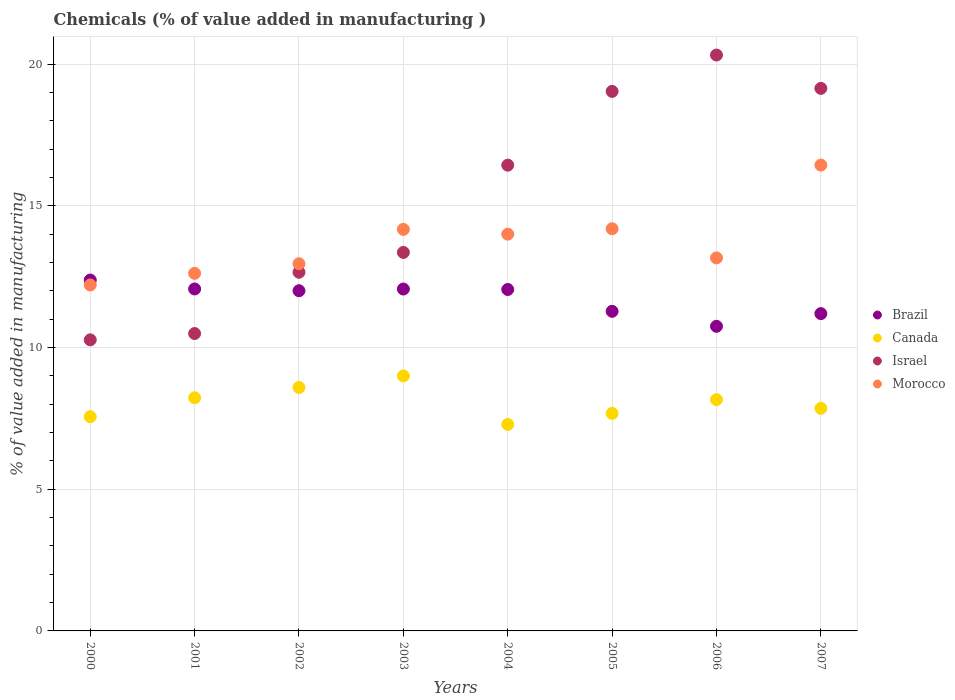How many different coloured dotlines are there?
Give a very brief answer. 4. Is the number of dotlines equal to the number of legend labels?
Your response must be concise. Yes. What is the value added in manufacturing chemicals in Morocco in 2002?
Keep it short and to the point. 12.96. Across all years, what is the maximum value added in manufacturing chemicals in Israel?
Ensure brevity in your answer.  20.32. Across all years, what is the minimum value added in manufacturing chemicals in Brazil?
Your answer should be very brief. 10.75. In which year was the value added in manufacturing chemicals in Brazil maximum?
Provide a succinct answer. 2000. In which year was the value added in manufacturing chemicals in Brazil minimum?
Provide a succinct answer. 2006. What is the total value added in manufacturing chemicals in Morocco in the graph?
Your answer should be very brief. 109.75. What is the difference between the value added in manufacturing chemicals in Israel in 2000 and that in 2002?
Offer a terse response. -2.39. What is the difference between the value added in manufacturing chemicals in Israel in 2006 and the value added in manufacturing chemicals in Morocco in 2001?
Provide a succinct answer. 7.7. What is the average value added in manufacturing chemicals in Israel per year?
Ensure brevity in your answer.  15.21. In the year 2003, what is the difference between the value added in manufacturing chemicals in Morocco and value added in manufacturing chemicals in Canada?
Offer a very short reply. 5.17. What is the ratio of the value added in manufacturing chemicals in Israel in 2000 to that in 2004?
Provide a succinct answer. 0.62. Is the value added in manufacturing chemicals in Israel in 2004 less than that in 2006?
Provide a short and direct response. Yes. What is the difference between the highest and the second highest value added in manufacturing chemicals in Brazil?
Provide a succinct answer. 0.31. What is the difference between the highest and the lowest value added in manufacturing chemicals in Brazil?
Offer a very short reply. 1.63. Is the sum of the value added in manufacturing chemicals in Israel in 2000 and 2006 greater than the maximum value added in manufacturing chemicals in Brazil across all years?
Keep it short and to the point. Yes. Is it the case that in every year, the sum of the value added in manufacturing chemicals in Israel and value added in manufacturing chemicals in Brazil  is greater than the sum of value added in manufacturing chemicals in Morocco and value added in manufacturing chemicals in Canada?
Provide a succinct answer. Yes. Is the value added in manufacturing chemicals in Brazil strictly greater than the value added in manufacturing chemicals in Morocco over the years?
Provide a succinct answer. No. How many years are there in the graph?
Keep it short and to the point. 8. What is the difference between two consecutive major ticks on the Y-axis?
Your response must be concise. 5. Does the graph contain any zero values?
Give a very brief answer. No. How many legend labels are there?
Keep it short and to the point. 4. What is the title of the graph?
Your answer should be compact. Chemicals (% of value added in manufacturing ). Does "Norway" appear as one of the legend labels in the graph?
Your answer should be compact. No. What is the label or title of the X-axis?
Your response must be concise. Years. What is the label or title of the Y-axis?
Offer a very short reply. % of value added in manufacturing. What is the % of value added in manufacturing in Brazil in 2000?
Your answer should be very brief. 12.38. What is the % of value added in manufacturing of Canada in 2000?
Make the answer very short. 7.56. What is the % of value added in manufacturing of Israel in 2000?
Your answer should be very brief. 10.27. What is the % of value added in manufacturing in Morocco in 2000?
Ensure brevity in your answer.  12.21. What is the % of value added in manufacturing in Brazil in 2001?
Offer a terse response. 12.07. What is the % of value added in manufacturing in Canada in 2001?
Your answer should be compact. 8.23. What is the % of value added in manufacturing in Israel in 2001?
Your answer should be compact. 10.49. What is the % of value added in manufacturing in Morocco in 2001?
Offer a very short reply. 12.62. What is the % of value added in manufacturing of Brazil in 2002?
Offer a terse response. 12. What is the % of value added in manufacturing of Canada in 2002?
Your response must be concise. 8.59. What is the % of value added in manufacturing in Israel in 2002?
Provide a short and direct response. 12.66. What is the % of value added in manufacturing of Morocco in 2002?
Provide a succinct answer. 12.96. What is the % of value added in manufacturing of Brazil in 2003?
Provide a succinct answer. 12.06. What is the % of value added in manufacturing in Canada in 2003?
Your answer should be compact. 9. What is the % of value added in manufacturing of Israel in 2003?
Make the answer very short. 13.36. What is the % of value added in manufacturing of Morocco in 2003?
Ensure brevity in your answer.  14.17. What is the % of value added in manufacturing of Brazil in 2004?
Your response must be concise. 12.05. What is the % of value added in manufacturing of Canada in 2004?
Your answer should be very brief. 7.29. What is the % of value added in manufacturing in Israel in 2004?
Provide a succinct answer. 16.43. What is the % of value added in manufacturing in Morocco in 2004?
Give a very brief answer. 14. What is the % of value added in manufacturing of Brazil in 2005?
Ensure brevity in your answer.  11.28. What is the % of value added in manufacturing in Canada in 2005?
Your answer should be very brief. 7.68. What is the % of value added in manufacturing of Israel in 2005?
Your answer should be very brief. 19.04. What is the % of value added in manufacturing of Morocco in 2005?
Offer a terse response. 14.19. What is the % of value added in manufacturing in Brazil in 2006?
Make the answer very short. 10.75. What is the % of value added in manufacturing of Canada in 2006?
Make the answer very short. 8.16. What is the % of value added in manufacturing in Israel in 2006?
Ensure brevity in your answer.  20.32. What is the % of value added in manufacturing in Morocco in 2006?
Provide a short and direct response. 13.16. What is the % of value added in manufacturing in Brazil in 2007?
Provide a succinct answer. 11.2. What is the % of value added in manufacturing in Canada in 2007?
Ensure brevity in your answer.  7.85. What is the % of value added in manufacturing in Israel in 2007?
Provide a short and direct response. 19.14. What is the % of value added in manufacturing in Morocco in 2007?
Your answer should be compact. 16.44. Across all years, what is the maximum % of value added in manufacturing in Brazil?
Ensure brevity in your answer.  12.38. Across all years, what is the maximum % of value added in manufacturing of Canada?
Ensure brevity in your answer.  9. Across all years, what is the maximum % of value added in manufacturing of Israel?
Your response must be concise. 20.32. Across all years, what is the maximum % of value added in manufacturing in Morocco?
Keep it short and to the point. 16.44. Across all years, what is the minimum % of value added in manufacturing in Brazil?
Give a very brief answer. 10.75. Across all years, what is the minimum % of value added in manufacturing in Canada?
Offer a terse response. 7.29. Across all years, what is the minimum % of value added in manufacturing in Israel?
Your response must be concise. 10.27. Across all years, what is the minimum % of value added in manufacturing of Morocco?
Make the answer very short. 12.21. What is the total % of value added in manufacturing of Brazil in the graph?
Keep it short and to the point. 93.79. What is the total % of value added in manufacturing in Canada in the graph?
Your response must be concise. 64.35. What is the total % of value added in manufacturing in Israel in the graph?
Offer a very short reply. 121.72. What is the total % of value added in manufacturing in Morocco in the graph?
Your answer should be compact. 109.75. What is the difference between the % of value added in manufacturing of Brazil in 2000 and that in 2001?
Ensure brevity in your answer.  0.32. What is the difference between the % of value added in manufacturing of Canada in 2000 and that in 2001?
Offer a very short reply. -0.67. What is the difference between the % of value added in manufacturing in Israel in 2000 and that in 2001?
Ensure brevity in your answer.  -0.22. What is the difference between the % of value added in manufacturing of Morocco in 2000 and that in 2001?
Offer a terse response. -0.41. What is the difference between the % of value added in manufacturing of Brazil in 2000 and that in 2002?
Your answer should be very brief. 0.38. What is the difference between the % of value added in manufacturing of Canada in 2000 and that in 2002?
Your response must be concise. -1.03. What is the difference between the % of value added in manufacturing of Israel in 2000 and that in 2002?
Keep it short and to the point. -2.38. What is the difference between the % of value added in manufacturing in Morocco in 2000 and that in 2002?
Your answer should be compact. -0.75. What is the difference between the % of value added in manufacturing of Brazil in 2000 and that in 2003?
Provide a short and direct response. 0.32. What is the difference between the % of value added in manufacturing of Canada in 2000 and that in 2003?
Provide a succinct answer. -1.44. What is the difference between the % of value added in manufacturing in Israel in 2000 and that in 2003?
Your answer should be very brief. -3.08. What is the difference between the % of value added in manufacturing in Morocco in 2000 and that in 2003?
Give a very brief answer. -1.96. What is the difference between the % of value added in manufacturing in Brazil in 2000 and that in 2004?
Your response must be concise. 0.33. What is the difference between the % of value added in manufacturing of Canada in 2000 and that in 2004?
Ensure brevity in your answer.  0.27. What is the difference between the % of value added in manufacturing in Israel in 2000 and that in 2004?
Offer a terse response. -6.16. What is the difference between the % of value added in manufacturing in Morocco in 2000 and that in 2004?
Your response must be concise. -1.79. What is the difference between the % of value added in manufacturing of Brazil in 2000 and that in 2005?
Offer a very short reply. 1.1. What is the difference between the % of value added in manufacturing of Canada in 2000 and that in 2005?
Offer a very short reply. -0.12. What is the difference between the % of value added in manufacturing of Israel in 2000 and that in 2005?
Ensure brevity in your answer.  -8.77. What is the difference between the % of value added in manufacturing of Morocco in 2000 and that in 2005?
Your answer should be very brief. -1.98. What is the difference between the % of value added in manufacturing of Brazil in 2000 and that in 2006?
Provide a short and direct response. 1.63. What is the difference between the % of value added in manufacturing in Canada in 2000 and that in 2006?
Keep it short and to the point. -0.6. What is the difference between the % of value added in manufacturing of Israel in 2000 and that in 2006?
Your answer should be very brief. -10.05. What is the difference between the % of value added in manufacturing of Morocco in 2000 and that in 2006?
Keep it short and to the point. -0.95. What is the difference between the % of value added in manufacturing of Brazil in 2000 and that in 2007?
Keep it short and to the point. 1.18. What is the difference between the % of value added in manufacturing in Canada in 2000 and that in 2007?
Your answer should be compact. -0.29. What is the difference between the % of value added in manufacturing in Israel in 2000 and that in 2007?
Provide a short and direct response. -8.87. What is the difference between the % of value added in manufacturing in Morocco in 2000 and that in 2007?
Ensure brevity in your answer.  -4.23. What is the difference between the % of value added in manufacturing of Brazil in 2001 and that in 2002?
Provide a succinct answer. 0.06. What is the difference between the % of value added in manufacturing in Canada in 2001 and that in 2002?
Your answer should be very brief. -0.36. What is the difference between the % of value added in manufacturing of Israel in 2001 and that in 2002?
Your response must be concise. -2.16. What is the difference between the % of value added in manufacturing in Morocco in 2001 and that in 2002?
Keep it short and to the point. -0.34. What is the difference between the % of value added in manufacturing of Brazil in 2001 and that in 2003?
Keep it short and to the point. 0. What is the difference between the % of value added in manufacturing of Canada in 2001 and that in 2003?
Offer a terse response. -0.77. What is the difference between the % of value added in manufacturing of Israel in 2001 and that in 2003?
Your answer should be compact. -2.86. What is the difference between the % of value added in manufacturing of Morocco in 2001 and that in 2003?
Keep it short and to the point. -1.55. What is the difference between the % of value added in manufacturing of Brazil in 2001 and that in 2004?
Your answer should be very brief. 0.02. What is the difference between the % of value added in manufacturing in Canada in 2001 and that in 2004?
Provide a succinct answer. 0.94. What is the difference between the % of value added in manufacturing in Israel in 2001 and that in 2004?
Make the answer very short. -5.94. What is the difference between the % of value added in manufacturing in Morocco in 2001 and that in 2004?
Ensure brevity in your answer.  -1.38. What is the difference between the % of value added in manufacturing of Brazil in 2001 and that in 2005?
Make the answer very short. 0.79. What is the difference between the % of value added in manufacturing in Canada in 2001 and that in 2005?
Your answer should be compact. 0.55. What is the difference between the % of value added in manufacturing of Israel in 2001 and that in 2005?
Keep it short and to the point. -8.54. What is the difference between the % of value added in manufacturing in Morocco in 2001 and that in 2005?
Provide a succinct answer. -1.57. What is the difference between the % of value added in manufacturing in Brazil in 2001 and that in 2006?
Offer a terse response. 1.32. What is the difference between the % of value added in manufacturing in Canada in 2001 and that in 2006?
Make the answer very short. 0.06. What is the difference between the % of value added in manufacturing of Israel in 2001 and that in 2006?
Your answer should be very brief. -9.83. What is the difference between the % of value added in manufacturing in Morocco in 2001 and that in 2006?
Provide a succinct answer. -0.54. What is the difference between the % of value added in manufacturing in Brazil in 2001 and that in 2007?
Provide a succinct answer. 0.87. What is the difference between the % of value added in manufacturing in Canada in 2001 and that in 2007?
Your answer should be very brief. 0.37. What is the difference between the % of value added in manufacturing in Israel in 2001 and that in 2007?
Make the answer very short. -8.65. What is the difference between the % of value added in manufacturing in Morocco in 2001 and that in 2007?
Make the answer very short. -3.82. What is the difference between the % of value added in manufacturing of Brazil in 2002 and that in 2003?
Your response must be concise. -0.06. What is the difference between the % of value added in manufacturing of Canada in 2002 and that in 2003?
Keep it short and to the point. -0.41. What is the difference between the % of value added in manufacturing in Israel in 2002 and that in 2003?
Your answer should be compact. -0.7. What is the difference between the % of value added in manufacturing in Morocco in 2002 and that in 2003?
Your answer should be compact. -1.21. What is the difference between the % of value added in manufacturing in Brazil in 2002 and that in 2004?
Your response must be concise. -0.04. What is the difference between the % of value added in manufacturing of Canada in 2002 and that in 2004?
Provide a short and direct response. 1.3. What is the difference between the % of value added in manufacturing of Israel in 2002 and that in 2004?
Your response must be concise. -3.78. What is the difference between the % of value added in manufacturing of Morocco in 2002 and that in 2004?
Provide a short and direct response. -1.04. What is the difference between the % of value added in manufacturing of Brazil in 2002 and that in 2005?
Provide a short and direct response. 0.73. What is the difference between the % of value added in manufacturing of Canada in 2002 and that in 2005?
Keep it short and to the point. 0.92. What is the difference between the % of value added in manufacturing of Israel in 2002 and that in 2005?
Give a very brief answer. -6.38. What is the difference between the % of value added in manufacturing of Morocco in 2002 and that in 2005?
Your answer should be compact. -1.24. What is the difference between the % of value added in manufacturing of Brazil in 2002 and that in 2006?
Give a very brief answer. 1.26. What is the difference between the % of value added in manufacturing of Canada in 2002 and that in 2006?
Give a very brief answer. 0.43. What is the difference between the % of value added in manufacturing of Israel in 2002 and that in 2006?
Your answer should be very brief. -7.66. What is the difference between the % of value added in manufacturing in Morocco in 2002 and that in 2006?
Provide a succinct answer. -0.21. What is the difference between the % of value added in manufacturing of Brazil in 2002 and that in 2007?
Your response must be concise. 0.81. What is the difference between the % of value added in manufacturing of Canada in 2002 and that in 2007?
Provide a short and direct response. 0.74. What is the difference between the % of value added in manufacturing of Israel in 2002 and that in 2007?
Offer a very short reply. -6.49. What is the difference between the % of value added in manufacturing of Morocco in 2002 and that in 2007?
Provide a succinct answer. -3.48. What is the difference between the % of value added in manufacturing of Brazil in 2003 and that in 2004?
Make the answer very short. 0.02. What is the difference between the % of value added in manufacturing in Canada in 2003 and that in 2004?
Give a very brief answer. 1.71. What is the difference between the % of value added in manufacturing of Israel in 2003 and that in 2004?
Offer a terse response. -3.08. What is the difference between the % of value added in manufacturing of Morocco in 2003 and that in 2004?
Offer a terse response. 0.17. What is the difference between the % of value added in manufacturing in Brazil in 2003 and that in 2005?
Keep it short and to the point. 0.79. What is the difference between the % of value added in manufacturing of Canada in 2003 and that in 2005?
Make the answer very short. 1.32. What is the difference between the % of value added in manufacturing in Israel in 2003 and that in 2005?
Your answer should be very brief. -5.68. What is the difference between the % of value added in manufacturing of Morocco in 2003 and that in 2005?
Make the answer very short. -0.02. What is the difference between the % of value added in manufacturing in Brazil in 2003 and that in 2006?
Your answer should be compact. 1.32. What is the difference between the % of value added in manufacturing in Canada in 2003 and that in 2006?
Your response must be concise. 0.84. What is the difference between the % of value added in manufacturing of Israel in 2003 and that in 2006?
Provide a short and direct response. -6.96. What is the difference between the % of value added in manufacturing in Morocco in 2003 and that in 2006?
Offer a terse response. 1.01. What is the difference between the % of value added in manufacturing in Brazil in 2003 and that in 2007?
Your answer should be very brief. 0.87. What is the difference between the % of value added in manufacturing in Canada in 2003 and that in 2007?
Your answer should be very brief. 1.14. What is the difference between the % of value added in manufacturing in Israel in 2003 and that in 2007?
Make the answer very short. -5.79. What is the difference between the % of value added in manufacturing of Morocco in 2003 and that in 2007?
Offer a very short reply. -2.27. What is the difference between the % of value added in manufacturing of Brazil in 2004 and that in 2005?
Your answer should be very brief. 0.77. What is the difference between the % of value added in manufacturing in Canada in 2004 and that in 2005?
Give a very brief answer. -0.39. What is the difference between the % of value added in manufacturing of Israel in 2004 and that in 2005?
Offer a terse response. -2.6. What is the difference between the % of value added in manufacturing of Morocco in 2004 and that in 2005?
Keep it short and to the point. -0.19. What is the difference between the % of value added in manufacturing in Brazil in 2004 and that in 2006?
Offer a terse response. 1.3. What is the difference between the % of value added in manufacturing in Canada in 2004 and that in 2006?
Make the answer very short. -0.88. What is the difference between the % of value added in manufacturing of Israel in 2004 and that in 2006?
Provide a succinct answer. -3.89. What is the difference between the % of value added in manufacturing of Morocco in 2004 and that in 2006?
Provide a short and direct response. 0.84. What is the difference between the % of value added in manufacturing in Brazil in 2004 and that in 2007?
Your answer should be compact. 0.85. What is the difference between the % of value added in manufacturing in Canada in 2004 and that in 2007?
Your answer should be compact. -0.57. What is the difference between the % of value added in manufacturing in Israel in 2004 and that in 2007?
Ensure brevity in your answer.  -2.71. What is the difference between the % of value added in manufacturing of Morocco in 2004 and that in 2007?
Give a very brief answer. -2.44. What is the difference between the % of value added in manufacturing of Brazil in 2005 and that in 2006?
Keep it short and to the point. 0.53. What is the difference between the % of value added in manufacturing of Canada in 2005 and that in 2006?
Give a very brief answer. -0.49. What is the difference between the % of value added in manufacturing of Israel in 2005 and that in 2006?
Offer a terse response. -1.28. What is the difference between the % of value added in manufacturing of Morocco in 2005 and that in 2006?
Make the answer very short. 1.03. What is the difference between the % of value added in manufacturing of Brazil in 2005 and that in 2007?
Provide a short and direct response. 0.08. What is the difference between the % of value added in manufacturing of Canada in 2005 and that in 2007?
Provide a short and direct response. -0.18. What is the difference between the % of value added in manufacturing in Israel in 2005 and that in 2007?
Your response must be concise. -0.11. What is the difference between the % of value added in manufacturing of Morocco in 2005 and that in 2007?
Offer a very short reply. -2.25. What is the difference between the % of value added in manufacturing in Brazil in 2006 and that in 2007?
Provide a short and direct response. -0.45. What is the difference between the % of value added in manufacturing in Canada in 2006 and that in 2007?
Your answer should be very brief. 0.31. What is the difference between the % of value added in manufacturing of Israel in 2006 and that in 2007?
Make the answer very short. 1.18. What is the difference between the % of value added in manufacturing in Morocco in 2006 and that in 2007?
Ensure brevity in your answer.  -3.28. What is the difference between the % of value added in manufacturing in Brazil in 2000 and the % of value added in manufacturing in Canada in 2001?
Keep it short and to the point. 4.15. What is the difference between the % of value added in manufacturing of Brazil in 2000 and the % of value added in manufacturing of Israel in 2001?
Your answer should be compact. 1.89. What is the difference between the % of value added in manufacturing in Brazil in 2000 and the % of value added in manufacturing in Morocco in 2001?
Offer a very short reply. -0.24. What is the difference between the % of value added in manufacturing in Canada in 2000 and the % of value added in manufacturing in Israel in 2001?
Your response must be concise. -2.93. What is the difference between the % of value added in manufacturing in Canada in 2000 and the % of value added in manufacturing in Morocco in 2001?
Give a very brief answer. -5.06. What is the difference between the % of value added in manufacturing in Israel in 2000 and the % of value added in manufacturing in Morocco in 2001?
Make the answer very short. -2.35. What is the difference between the % of value added in manufacturing in Brazil in 2000 and the % of value added in manufacturing in Canada in 2002?
Offer a very short reply. 3.79. What is the difference between the % of value added in manufacturing in Brazil in 2000 and the % of value added in manufacturing in Israel in 2002?
Your answer should be very brief. -0.27. What is the difference between the % of value added in manufacturing of Brazil in 2000 and the % of value added in manufacturing of Morocco in 2002?
Provide a succinct answer. -0.58. What is the difference between the % of value added in manufacturing in Canada in 2000 and the % of value added in manufacturing in Israel in 2002?
Make the answer very short. -5.1. What is the difference between the % of value added in manufacturing in Canada in 2000 and the % of value added in manufacturing in Morocco in 2002?
Offer a very short reply. -5.4. What is the difference between the % of value added in manufacturing in Israel in 2000 and the % of value added in manufacturing in Morocco in 2002?
Your answer should be compact. -2.69. What is the difference between the % of value added in manufacturing in Brazil in 2000 and the % of value added in manufacturing in Canada in 2003?
Ensure brevity in your answer.  3.38. What is the difference between the % of value added in manufacturing in Brazil in 2000 and the % of value added in manufacturing in Israel in 2003?
Your response must be concise. -0.97. What is the difference between the % of value added in manufacturing of Brazil in 2000 and the % of value added in manufacturing of Morocco in 2003?
Offer a very short reply. -1.79. What is the difference between the % of value added in manufacturing of Canada in 2000 and the % of value added in manufacturing of Israel in 2003?
Provide a short and direct response. -5.8. What is the difference between the % of value added in manufacturing of Canada in 2000 and the % of value added in manufacturing of Morocco in 2003?
Give a very brief answer. -6.61. What is the difference between the % of value added in manufacturing in Israel in 2000 and the % of value added in manufacturing in Morocco in 2003?
Give a very brief answer. -3.9. What is the difference between the % of value added in manufacturing of Brazil in 2000 and the % of value added in manufacturing of Canada in 2004?
Your response must be concise. 5.1. What is the difference between the % of value added in manufacturing in Brazil in 2000 and the % of value added in manufacturing in Israel in 2004?
Ensure brevity in your answer.  -4.05. What is the difference between the % of value added in manufacturing in Brazil in 2000 and the % of value added in manufacturing in Morocco in 2004?
Provide a short and direct response. -1.62. What is the difference between the % of value added in manufacturing in Canada in 2000 and the % of value added in manufacturing in Israel in 2004?
Your answer should be compact. -8.88. What is the difference between the % of value added in manufacturing of Canada in 2000 and the % of value added in manufacturing of Morocco in 2004?
Make the answer very short. -6.44. What is the difference between the % of value added in manufacturing of Israel in 2000 and the % of value added in manufacturing of Morocco in 2004?
Your response must be concise. -3.73. What is the difference between the % of value added in manufacturing of Brazil in 2000 and the % of value added in manufacturing of Canada in 2005?
Your response must be concise. 4.71. What is the difference between the % of value added in manufacturing in Brazil in 2000 and the % of value added in manufacturing in Israel in 2005?
Ensure brevity in your answer.  -6.66. What is the difference between the % of value added in manufacturing of Brazil in 2000 and the % of value added in manufacturing of Morocco in 2005?
Give a very brief answer. -1.81. What is the difference between the % of value added in manufacturing in Canada in 2000 and the % of value added in manufacturing in Israel in 2005?
Provide a succinct answer. -11.48. What is the difference between the % of value added in manufacturing in Canada in 2000 and the % of value added in manufacturing in Morocco in 2005?
Provide a short and direct response. -6.63. What is the difference between the % of value added in manufacturing of Israel in 2000 and the % of value added in manufacturing of Morocco in 2005?
Your response must be concise. -3.92. What is the difference between the % of value added in manufacturing of Brazil in 2000 and the % of value added in manufacturing of Canada in 2006?
Make the answer very short. 4.22. What is the difference between the % of value added in manufacturing of Brazil in 2000 and the % of value added in manufacturing of Israel in 2006?
Keep it short and to the point. -7.94. What is the difference between the % of value added in manufacturing of Brazil in 2000 and the % of value added in manufacturing of Morocco in 2006?
Offer a terse response. -0.78. What is the difference between the % of value added in manufacturing of Canada in 2000 and the % of value added in manufacturing of Israel in 2006?
Ensure brevity in your answer.  -12.76. What is the difference between the % of value added in manufacturing of Canada in 2000 and the % of value added in manufacturing of Morocco in 2006?
Your answer should be compact. -5.6. What is the difference between the % of value added in manufacturing in Israel in 2000 and the % of value added in manufacturing in Morocco in 2006?
Ensure brevity in your answer.  -2.89. What is the difference between the % of value added in manufacturing in Brazil in 2000 and the % of value added in manufacturing in Canada in 2007?
Your answer should be very brief. 4.53. What is the difference between the % of value added in manufacturing in Brazil in 2000 and the % of value added in manufacturing in Israel in 2007?
Give a very brief answer. -6.76. What is the difference between the % of value added in manufacturing in Brazil in 2000 and the % of value added in manufacturing in Morocco in 2007?
Make the answer very short. -4.06. What is the difference between the % of value added in manufacturing in Canada in 2000 and the % of value added in manufacturing in Israel in 2007?
Offer a terse response. -11.58. What is the difference between the % of value added in manufacturing of Canada in 2000 and the % of value added in manufacturing of Morocco in 2007?
Keep it short and to the point. -8.88. What is the difference between the % of value added in manufacturing of Israel in 2000 and the % of value added in manufacturing of Morocco in 2007?
Provide a short and direct response. -6.17. What is the difference between the % of value added in manufacturing of Brazil in 2001 and the % of value added in manufacturing of Canada in 2002?
Your response must be concise. 3.48. What is the difference between the % of value added in manufacturing in Brazil in 2001 and the % of value added in manufacturing in Israel in 2002?
Make the answer very short. -0.59. What is the difference between the % of value added in manufacturing in Brazil in 2001 and the % of value added in manufacturing in Morocco in 2002?
Keep it short and to the point. -0.89. What is the difference between the % of value added in manufacturing of Canada in 2001 and the % of value added in manufacturing of Israel in 2002?
Give a very brief answer. -4.43. What is the difference between the % of value added in manufacturing in Canada in 2001 and the % of value added in manufacturing in Morocco in 2002?
Offer a terse response. -4.73. What is the difference between the % of value added in manufacturing of Israel in 2001 and the % of value added in manufacturing of Morocco in 2002?
Keep it short and to the point. -2.46. What is the difference between the % of value added in manufacturing in Brazil in 2001 and the % of value added in manufacturing in Canada in 2003?
Provide a short and direct response. 3.07. What is the difference between the % of value added in manufacturing of Brazil in 2001 and the % of value added in manufacturing of Israel in 2003?
Ensure brevity in your answer.  -1.29. What is the difference between the % of value added in manufacturing of Brazil in 2001 and the % of value added in manufacturing of Morocco in 2003?
Provide a short and direct response. -2.1. What is the difference between the % of value added in manufacturing of Canada in 2001 and the % of value added in manufacturing of Israel in 2003?
Your answer should be compact. -5.13. What is the difference between the % of value added in manufacturing in Canada in 2001 and the % of value added in manufacturing in Morocco in 2003?
Keep it short and to the point. -5.94. What is the difference between the % of value added in manufacturing in Israel in 2001 and the % of value added in manufacturing in Morocco in 2003?
Your answer should be compact. -3.68. What is the difference between the % of value added in manufacturing of Brazil in 2001 and the % of value added in manufacturing of Canada in 2004?
Your response must be concise. 4.78. What is the difference between the % of value added in manufacturing in Brazil in 2001 and the % of value added in manufacturing in Israel in 2004?
Keep it short and to the point. -4.37. What is the difference between the % of value added in manufacturing of Brazil in 2001 and the % of value added in manufacturing of Morocco in 2004?
Your answer should be very brief. -1.93. What is the difference between the % of value added in manufacturing of Canada in 2001 and the % of value added in manufacturing of Israel in 2004?
Make the answer very short. -8.21. What is the difference between the % of value added in manufacturing in Canada in 2001 and the % of value added in manufacturing in Morocco in 2004?
Offer a terse response. -5.77. What is the difference between the % of value added in manufacturing in Israel in 2001 and the % of value added in manufacturing in Morocco in 2004?
Your answer should be compact. -3.51. What is the difference between the % of value added in manufacturing in Brazil in 2001 and the % of value added in manufacturing in Canada in 2005?
Provide a short and direct response. 4.39. What is the difference between the % of value added in manufacturing in Brazil in 2001 and the % of value added in manufacturing in Israel in 2005?
Give a very brief answer. -6.97. What is the difference between the % of value added in manufacturing in Brazil in 2001 and the % of value added in manufacturing in Morocco in 2005?
Provide a succinct answer. -2.13. What is the difference between the % of value added in manufacturing of Canada in 2001 and the % of value added in manufacturing of Israel in 2005?
Your response must be concise. -10.81. What is the difference between the % of value added in manufacturing in Canada in 2001 and the % of value added in manufacturing in Morocco in 2005?
Provide a succinct answer. -5.96. What is the difference between the % of value added in manufacturing of Israel in 2001 and the % of value added in manufacturing of Morocco in 2005?
Give a very brief answer. -3.7. What is the difference between the % of value added in manufacturing of Brazil in 2001 and the % of value added in manufacturing of Canada in 2006?
Ensure brevity in your answer.  3.9. What is the difference between the % of value added in manufacturing in Brazil in 2001 and the % of value added in manufacturing in Israel in 2006?
Ensure brevity in your answer.  -8.25. What is the difference between the % of value added in manufacturing in Brazil in 2001 and the % of value added in manufacturing in Morocco in 2006?
Your answer should be very brief. -1.1. What is the difference between the % of value added in manufacturing in Canada in 2001 and the % of value added in manufacturing in Israel in 2006?
Your response must be concise. -12.09. What is the difference between the % of value added in manufacturing in Canada in 2001 and the % of value added in manufacturing in Morocco in 2006?
Keep it short and to the point. -4.94. What is the difference between the % of value added in manufacturing in Israel in 2001 and the % of value added in manufacturing in Morocco in 2006?
Offer a terse response. -2.67. What is the difference between the % of value added in manufacturing in Brazil in 2001 and the % of value added in manufacturing in Canada in 2007?
Offer a very short reply. 4.21. What is the difference between the % of value added in manufacturing in Brazil in 2001 and the % of value added in manufacturing in Israel in 2007?
Your answer should be very brief. -7.08. What is the difference between the % of value added in manufacturing in Brazil in 2001 and the % of value added in manufacturing in Morocco in 2007?
Offer a terse response. -4.37. What is the difference between the % of value added in manufacturing in Canada in 2001 and the % of value added in manufacturing in Israel in 2007?
Make the answer very short. -10.92. What is the difference between the % of value added in manufacturing in Canada in 2001 and the % of value added in manufacturing in Morocco in 2007?
Ensure brevity in your answer.  -8.21. What is the difference between the % of value added in manufacturing of Israel in 2001 and the % of value added in manufacturing of Morocco in 2007?
Your response must be concise. -5.94. What is the difference between the % of value added in manufacturing of Brazil in 2002 and the % of value added in manufacturing of Canada in 2003?
Make the answer very short. 3.01. What is the difference between the % of value added in manufacturing of Brazil in 2002 and the % of value added in manufacturing of Israel in 2003?
Provide a succinct answer. -1.35. What is the difference between the % of value added in manufacturing of Brazil in 2002 and the % of value added in manufacturing of Morocco in 2003?
Your answer should be very brief. -2.16. What is the difference between the % of value added in manufacturing in Canada in 2002 and the % of value added in manufacturing in Israel in 2003?
Ensure brevity in your answer.  -4.77. What is the difference between the % of value added in manufacturing of Canada in 2002 and the % of value added in manufacturing of Morocco in 2003?
Provide a short and direct response. -5.58. What is the difference between the % of value added in manufacturing of Israel in 2002 and the % of value added in manufacturing of Morocco in 2003?
Your answer should be very brief. -1.51. What is the difference between the % of value added in manufacturing in Brazil in 2002 and the % of value added in manufacturing in Canada in 2004?
Give a very brief answer. 4.72. What is the difference between the % of value added in manufacturing in Brazil in 2002 and the % of value added in manufacturing in Israel in 2004?
Give a very brief answer. -4.43. What is the difference between the % of value added in manufacturing in Brazil in 2002 and the % of value added in manufacturing in Morocco in 2004?
Ensure brevity in your answer.  -2. What is the difference between the % of value added in manufacturing in Canada in 2002 and the % of value added in manufacturing in Israel in 2004?
Keep it short and to the point. -7.84. What is the difference between the % of value added in manufacturing of Canada in 2002 and the % of value added in manufacturing of Morocco in 2004?
Your answer should be compact. -5.41. What is the difference between the % of value added in manufacturing of Israel in 2002 and the % of value added in manufacturing of Morocco in 2004?
Provide a short and direct response. -1.34. What is the difference between the % of value added in manufacturing in Brazil in 2002 and the % of value added in manufacturing in Canada in 2005?
Offer a very short reply. 4.33. What is the difference between the % of value added in manufacturing of Brazil in 2002 and the % of value added in manufacturing of Israel in 2005?
Keep it short and to the point. -7.03. What is the difference between the % of value added in manufacturing in Brazil in 2002 and the % of value added in manufacturing in Morocco in 2005?
Give a very brief answer. -2.19. What is the difference between the % of value added in manufacturing of Canada in 2002 and the % of value added in manufacturing of Israel in 2005?
Your answer should be very brief. -10.45. What is the difference between the % of value added in manufacturing in Canada in 2002 and the % of value added in manufacturing in Morocco in 2005?
Provide a short and direct response. -5.6. What is the difference between the % of value added in manufacturing in Israel in 2002 and the % of value added in manufacturing in Morocco in 2005?
Give a very brief answer. -1.54. What is the difference between the % of value added in manufacturing of Brazil in 2002 and the % of value added in manufacturing of Canada in 2006?
Make the answer very short. 3.84. What is the difference between the % of value added in manufacturing of Brazil in 2002 and the % of value added in manufacturing of Israel in 2006?
Offer a terse response. -8.32. What is the difference between the % of value added in manufacturing of Brazil in 2002 and the % of value added in manufacturing of Morocco in 2006?
Provide a short and direct response. -1.16. What is the difference between the % of value added in manufacturing of Canada in 2002 and the % of value added in manufacturing of Israel in 2006?
Your answer should be compact. -11.73. What is the difference between the % of value added in manufacturing of Canada in 2002 and the % of value added in manufacturing of Morocco in 2006?
Offer a very short reply. -4.57. What is the difference between the % of value added in manufacturing of Israel in 2002 and the % of value added in manufacturing of Morocco in 2006?
Offer a terse response. -0.51. What is the difference between the % of value added in manufacturing in Brazil in 2002 and the % of value added in manufacturing in Canada in 2007?
Your answer should be compact. 4.15. What is the difference between the % of value added in manufacturing in Brazil in 2002 and the % of value added in manufacturing in Israel in 2007?
Offer a terse response. -7.14. What is the difference between the % of value added in manufacturing of Brazil in 2002 and the % of value added in manufacturing of Morocco in 2007?
Give a very brief answer. -4.43. What is the difference between the % of value added in manufacturing of Canada in 2002 and the % of value added in manufacturing of Israel in 2007?
Provide a short and direct response. -10.55. What is the difference between the % of value added in manufacturing of Canada in 2002 and the % of value added in manufacturing of Morocco in 2007?
Offer a terse response. -7.85. What is the difference between the % of value added in manufacturing in Israel in 2002 and the % of value added in manufacturing in Morocco in 2007?
Give a very brief answer. -3.78. What is the difference between the % of value added in manufacturing of Brazil in 2003 and the % of value added in manufacturing of Canada in 2004?
Keep it short and to the point. 4.78. What is the difference between the % of value added in manufacturing of Brazil in 2003 and the % of value added in manufacturing of Israel in 2004?
Your answer should be compact. -4.37. What is the difference between the % of value added in manufacturing in Brazil in 2003 and the % of value added in manufacturing in Morocco in 2004?
Your answer should be compact. -1.94. What is the difference between the % of value added in manufacturing in Canada in 2003 and the % of value added in manufacturing in Israel in 2004?
Offer a terse response. -7.44. What is the difference between the % of value added in manufacturing in Canada in 2003 and the % of value added in manufacturing in Morocco in 2004?
Your answer should be very brief. -5. What is the difference between the % of value added in manufacturing in Israel in 2003 and the % of value added in manufacturing in Morocco in 2004?
Provide a succinct answer. -0.64. What is the difference between the % of value added in manufacturing in Brazil in 2003 and the % of value added in manufacturing in Canada in 2005?
Provide a succinct answer. 4.39. What is the difference between the % of value added in manufacturing in Brazil in 2003 and the % of value added in manufacturing in Israel in 2005?
Keep it short and to the point. -6.97. What is the difference between the % of value added in manufacturing in Brazil in 2003 and the % of value added in manufacturing in Morocco in 2005?
Your answer should be very brief. -2.13. What is the difference between the % of value added in manufacturing of Canada in 2003 and the % of value added in manufacturing of Israel in 2005?
Offer a terse response. -10.04. What is the difference between the % of value added in manufacturing of Canada in 2003 and the % of value added in manufacturing of Morocco in 2005?
Ensure brevity in your answer.  -5.19. What is the difference between the % of value added in manufacturing in Israel in 2003 and the % of value added in manufacturing in Morocco in 2005?
Your response must be concise. -0.84. What is the difference between the % of value added in manufacturing in Brazil in 2003 and the % of value added in manufacturing in Canada in 2006?
Offer a terse response. 3.9. What is the difference between the % of value added in manufacturing of Brazil in 2003 and the % of value added in manufacturing of Israel in 2006?
Your answer should be compact. -8.26. What is the difference between the % of value added in manufacturing in Brazil in 2003 and the % of value added in manufacturing in Morocco in 2006?
Your answer should be very brief. -1.1. What is the difference between the % of value added in manufacturing in Canada in 2003 and the % of value added in manufacturing in Israel in 2006?
Offer a terse response. -11.32. What is the difference between the % of value added in manufacturing of Canada in 2003 and the % of value added in manufacturing of Morocco in 2006?
Your answer should be very brief. -4.16. What is the difference between the % of value added in manufacturing of Israel in 2003 and the % of value added in manufacturing of Morocco in 2006?
Offer a very short reply. 0.19. What is the difference between the % of value added in manufacturing of Brazil in 2003 and the % of value added in manufacturing of Canada in 2007?
Give a very brief answer. 4.21. What is the difference between the % of value added in manufacturing of Brazil in 2003 and the % of value added in manufacturing of Israel in 2007?
Ensure brevity in your answer.  -7.08. What is the difference between the % of value added in manufacturing of Brazil in 2003 and the % of value added in manufacturing of Morocco in 2007?
Provide a short and direct response. -4.37. What is the difference between the % of value added in manufacturing of Canada in 2003 and the % of value added in manufacturing of Israel in 2007?
Give a very brief answer. -10.15. What is the difference between the % of value added in manufacturing of Canada in 2003 and the % of value added in manufacturing of Morocco in 2007?
Make the answer very short. -7.44. What is the difference between the % of value added in manufacturing in Israel in 2003 and the % of value added in manufacturing in Morocco in 2007?
Keep it short and to the point. -3.08. What is the difference between the % of value added in manufacturing in Brazil in 2004 and the % of value added in manufacturing in Canada in 2005?
Provide a short and direct response. 4.37. What is the difference between the % of value added in manufacturing in Brazil in 2004 and the % of value added in manufacturing in Israel in 2005?
Make the answer very short. -6.99. What is the difference between the % of value added in manufacturing in Brazil in 2004 and the % of value added in manufacturing in Morocco in 2005?
Your answer should be compact. -2.14. What is the difference between the % of value added in manufacturing in Canada in 2004 and the % of value added in manufacturing in Israel in 2005?
Give a very brief answer. -11.75. What is the difference between the % of value added in manufacturing of Canada in 2004 and the % of value added in manufacturing of Morocco in 2005?
Give a very brief answer. -6.91. What is the difference between the % of value added in manufacturing in Israel in 2004 and the % of value added in manufacturing in Morocco in 2005?
Ensure brevity in your answer.  2.24. What is the difference between the % of value added in manufacturing of Brazil in 2004 and the % of value added in manufacturing of Canada in 2006?
Provide a short and direct response. 3.89. What is the difference between the % of value added in manufacturing of Brazil in 2004 and the % of value added in manufacturing of Israel in 2006?
Offer a very short reply. -8.27. What is the difference between the % of value added in manufacturing of Brazil in 2004 and the % of value added in manufacturing of Morocco in 2006?
Give a very brief answer. -1.11. What is the difference between the % of value added in manufacturing in Canada in 2004 and the % of value added in manufacturing in Israel in 2006?
Provide a succinct answer. -13.04. What is the difference between the % of value added in manufacturing in Canada in 2004 and the % of value added in manufacturing in Morocco in 2006?
Your answer should be compact. -5.88. What is the difference between the % of value added in manufacturing of Israel in 2004 and the % of value added in manufacturing of Morocco in 2006?
Provide a succinct answer. 3.27. What is the difference between the % of value added in manufacturing in Brazil in 2004 and the % of value added in manufacturing in Canada in 2007?
Give a very brief answer. 4.19. What is the difference between the % of value added in manufacturing in Brazil in 2004 and the % of value added in manufacturing in Israel in 2007?
Give a very brief answer. -7.1. What is the difference between the % of value added in manufacturing in Brazil in 2004 and the % of value added in manufacturing in Morocco in 2007?
Ensure brevity in your answer.  -4.39. What is the difference between the % of value added in manufacturing in Canada in 2004 and the % of value added in manufacturing in Israel in 2007?
Your answer should be compact. -11.86. What is the difference between the % of value added in manufacturing of Canada in 2004 and the % of value added in manufacturing of Morocco in 2007?
Keep it short and to the point. -9.15. What is the difference between the % of value added in manufacturing of Israel in 2004 and the % of value added in manufacturing of Morocco in 2007?
Offer a terse response. -0. What is the difference between the % of value added in manufacturing in Brazil in 2005 and the % of value added in manufacturing in Canada in 2006?
Provide a succinct answer. 3.12. What is the difference between the % of value added in manufacturing in Brazil in 2005 and the % of value added in manufacturing in Israel in 2006?
Your answer should be very brief. -9.04. What is the difference between the % of value added in manufacturing of Brazil in 2005 and the % of value added in manufacturing of Morocco in 2006?
Provide a succinct answer. -1.89. What is the difference between the % of value added in manufacturing of Canada in 2005 and the % of value added in manufacturing of Israel in 2006?
Your answer should be compact. -12.65. What is the difference between the % of value added in manufacturing in Canada in 2005 and the % of value added in manufacturing in Morocco in 2006?
Give a very brief answer. -5.49. What is the difference between the % of value added in manufacturing of Israel in 2005 and the % of value added in manufacturing of Morocco in 2006?
Offer a very short reply. 5.88. What is the difference between the % of value added in manufacturing of Brazil in 2005 and the % of value added in manufacturing of Canada in 2007?
Keep it short and to the point. 3.42. What is the difference between the % of value added in manufacturing of Brazil in 2005 and the % of value added in manufacturing of Israel in 2007?
Make the answer very short. -7.87. What is the difference between the % of value added in manufacturing in Brazil in 2005 and the % of value added in manufacturing in Morocco in 2007?
Your response must be concise. -5.16. What is the difference between the % of value added in manufacturing of Canada in 2005 and the % of value added in manufacturing of Israel in 2007?
Provide a succinct answer. -11.47. What is the difference between the % of value added in manufacturing in Canada in 2005 and the % of value added in manufacturing in Morocco in 2007?
Provide a short and direct response. -8.76. What is the difference between the % of value added in manufacturing in Israel in 2005 and the % of value added in manufacturing in Morocco in 2007?
Give a very brief answer. 2.6. What is the difference between the % of value added in manufacturing in Brazil in 2006 and the % of value added in manufacturing in Canada in 2007?
Your response must be concise. 2.89. What is the difference between the % of value added in manufacturing in Brazil in 2006 and the % of value added in manufacturing in Israel in 2007?
Offer a very short reply. -8.4. What is the difference between the % of value added in manufacturing in Brazil in 2006 and the % of value added in manufacturing in Morocco in 2007?
Offer a terse response. -5.69. What is the difference between the % of value added in manufacturing in Canada in 2006 and the % of value added in manufacturing in Israel in 2007?
Your response must be concise. -10.98. What is the difference between the % of value added in manufacturing of Canada in 2006 and the % of value added in manufacturing of Morocco in 2007?
Keep it short and to the point. -8.28. What is the difference between the % of value added in manufacturing of Israel in 2006 and the % of value added in manufacturing of Morocco in 2007?
Give a very brief answer. 3.88. What is the average % of value added in manufacturing in Brazil per year?
Provide a succinct answer. 11.72. What is the average % of value added in manufacturing of Canada per year?
Provide a succinct answer. 8.04. What is the average % of value added in manufacturing in Israel per year?
Provide a short and direct response. 15.21. What is the average % of value added in manufacturing of Morocco per year?
Your response must be concise. 13.72. In the year 2000, what is the difference between the % of value added in manufacturing of Brazil and % of value added in manufacturing of Canada?
Provide a succinct answer. 4.82. In the year 2000, what is the difference between the % of value added in manufacturing of Brazil and % of value added in manufacturing of Israel?
Make the answer very short. 2.11. In the year 2000, what is the difference between the % of value added in manufacturing of Brazil and % of value added in manufacturing of Morocco?
Your answer should be compact. 0.17. In the year 2000, what is the difference between the % of value added in manufacturing in Canada and % of value added in manufacturing in Israel?
Offer a terse response. -2.71. In the year 2000, what is the difference between the % of value added in manufacturing of Canada and % of value added in manufacturing of Morocco?
Offer a terse response. -4.65. In the year 2000, what is the difference between the % of value added in manufacturing in Israel and % of value added in manufacturing in Morocco?
Your response must be concise. -1.94. In the year 2001, what is the difference between the % of value added in manufacturing of Brazil and % of value added in manufacturing of Canada?
Offer a very short reply. 3.84. In the year 2001, what is the difference between the % of value added in manufacturing of Brazil and % of value added in manufacturing of Israel?
Offer a very short reply. 1.57. In the year 2001, what is the difference between the % of value added in manufacturing of Brazil and % of value added in manufacturing of Morocco?
Provide a succinct answer. -0.55. In the year 2001, what is the difference between the % of value added in manufacturing of Canada and % of value added in manufacturing of Israel?
Give a very brief answer. -2.27. In the year 2001, what is the difference between the % of value added in manufacturing of Canada and % of value added in manufacturing of Morocco?
Give a very brief answer. -4.39. In the year 2001, what is the difference between the % of value added in manufacturing in Israel and % of value added in manufacturing in Morocco?
Your answer should be very brief. -2.12. In the year 2002, what is the difference between the % of value added in manufacturing of Brazil and % of value added in manufacturing of Canada?
Provide a short and direct response. 3.41. In the year 2002, what is the difference between the % of value added in manufacturing in Brazil and % of value added in manufacturing in Israel?
Make the answer very short. -0.65. In the year 2002, what is the difference between the % of value added in manufacturing in Brazil and % of value added in manufacturing in Morocco?
Keep it short and to the point. -0.95. In the year 2002, what is the difference between the % of value added in manufacturing in Canada and % of value added in manufacturing in Israel?
Your answer should be very brief. -4.07. In the year 2002, what is the difference between the % of value added in manufacturing of Canada and % of value added in manufacturing of Morocco?
Offer a terse response. -4.37. In the year 2002, what is the difference between the % of value added in manufacturing of Israel and % of value added in manufacturing of Morocco?
Make the answer very short. -0.3. In the year 2003, what is the difference between the % of value added in manufacturing in Brazil and % of value added in manufacturing in Canada?
Your answer should be very brief. 3.07. In the year 2003, what is the difference between the % of value added in manufacturing of Brazil and % of value added in manufacturing of Israel?
Give a very brief answer. -1.29. In the year 2003, what is the difference between the % of value added in manufacturing in Brazil and % of value added in manufacturing in Morocco?
Offer a terse response. -2.11. In the year 2003, what is the difference between the % of value added in manufacturing of Canada and % of value added in manufacturing of Israel?
Keep it short and to the point. -4.36. In the year 2003, what is the difference between the % of value added in manufacturing in Canada and % of value added in manufacturing in Morocco?
Keep it short and to the point. -5.17. In the year 2003, what is the difference between the % of value added in manufacturing in Israel and % of value added in manufacturing in Morocco?
Your answer should be compact. -0.81. In the year 2004, what is the difference between the % of value added in manufacturing of Brazil and % of value added in manufacturing of Canada?
Your answer should be compact. 4.76. In the year 2004, what is the difference between the % of value added in manufacturing of Brazil and % of value added in manufacturing of Israel?
Give a very brief answer. -4.39. In the year 2004, what is the difference between the % of value added in manufacturing of Brazil and % of value added in manufacturing of Morocco?
Make the answer very short. -1.95. In the year 2004, what is the difference between the % of value added in manufacturing in Canada and % of value added in manufacturing in Israel?
Your response must be concise. -9.15. In the year 2004, what is the difference between the % of value added in manufacturing in Canada and % of value added in manufacturing in Morocco?
Offer a terse response. -6.71. In the year 2004, what is the difference between the % of value added in manufacturing of Israel and % of value added in manufacturing of Morocco?
Provide a succinct answer. 2.43. In the year 2005, what is the difference between the % of value added in manufacturing of Brazil and % of value added in manufacturing of Canada?
Your answer should be very brief. 3.6. In the year 2005, what is the difference between the % of value added in manufacturing in Brazil and % of value added in manufacturing in Israel?
Keep it short and to the point. -7.76. In the year 2005, what is the difference between the % of value added in manufacturing in Brazil and % of value added in manufacturing in Morocco?
Ensure brevity in your answer.  -2.91. In the year 2005, what is the difference between the % of value added in manufacturing in Canada and % of value added in manufacturing in Israel?
Keep it short and to the point. -11.36. In the year 2005, what is the difference between the % of value added in manufacturing of Canada and % of value added in manufacturing of Morocco?
Provide a short and direct response. -6.52. In the year 2005, what is the difference between the % of value added in manufacturing of Israel and % of value added in manufacturing of Morocco?
Your answer should be very brief. 4.85. In the year 2006, what is the difference between the % of value added in manufacturing in Brazil and % of value added in manufacturing in Canada?
Make the answer very short. 2.59. In the year 2006, what is the difference between the % of value added in manufacturing in Brazil and % of value added in manufacturing in Israel?
Your response must be concise. -9.57. In the year 2006, what is the difference between the % of value added in manufacturing in Brazil and % of value added in manufacturing in Morocco?
Make the answer very short. -2.41. In the year 2006, what is the difference between the % of value added in manufacturing in Canada and % of value added in manufacturing in Israel?
Your response must be concise. -12.16. In the year 2006, what is the difference between the % of value added in manufacturing of Canada and % of value added in manufacturing of Morocco?
Your answer should be compact. -5. In the year 2006, what is the difference between the % of value added in manufacturing in Israel and % of value added in manufacturing in Morocco?
Make the answer very short. 7.16. In the year 2007, what is the difference between the % of value added in manufacturing of Brazil and % of value added in manufacturing of Canada?
Make the answer very short. 3.34. In the year 2007, what is the difference between the % of value added in manufacturing of Brazil and % of value added in manufacturing of Israel?
Provide a short and direct response. -7.95. In the year 2007, what is the difference between the % of value added in manufacturing in Brazil and % of value added in manufacturing in Morocco?
Give a very brief answer. -5.24. In the year 2007, what is the difference between the % of value added in manufacturing in Canada and % of value added in manufacturing in Israel?
Make the answer very short. -11.29. In the year 2007, what is the difference between the % of value added in manufacturing of Canada and % of value added in manufacturing of Morocco?
Provide a succinct answer. -8.58. In the year 2007, what is the difference between the % of value added in manufacturing of Israel and % of value added in manufacturing of Morocco?
Your answer should be very brief. 2.71. What is the ratio of the % of value added in manufacturing of Brazil in 2000 to that in 2001?
Provide a short and direct response. 1.03. What is the ratio of the % of value added in manufacturing in Canada in 2000 to that in 2001?
Give a very brief answer. 0.92. What is the ratio of the % of value added in manufacturing of Israel in 2000 to that in 2001?
Ensure brevity in your answer.  0.98. What is the ratio of the % of value added in manufacturing of Morocco in 2000 to that in 2001?
Ensure brevity in your answer.  0.97. What is the ratio of the % of value added in manufacturing of Brazil in 2000 to that in 2002?
Your answer should be compact. 1.03. What is the ratio of the % of value added in manufacturing in Israel in 2000 to that in 2002?
Provide a short and direct response. 0.81. What is the ratio of the % of value added in manufacturing of Morocco in 2000 to that in 2002?
Make the answer very short. 0.94. What is the ratio of the % of value added in manufacturing of Brazil in 2000 to that in 2003?
Give a very brief answer. 1.03. What is the ratio of the % of value added in manufacturing of Canada in 2000 to that in 2003?
Your answer should be very brief. 0.84. What is the ratio of the % of value added in manufacturing of Israel in 2000 to that in 2003?
Provide a short and direct response. 0.77. What is the ratio of the % of value added in manufacturing of Morocco in 2000 to that in 2003?
Keep it short and to the point. 0.86. What is the ratio of the % of value added in manufacturing in Brazil in 2000 to that in 2004?
Make the answer very short. 1.03. What is the ratio of the % of value added in manufacturing in Canada in 2000 to that in 2004?
Offer a very short reply. 1.04. What is the ratio of the % of value added in manufacturing of Morocco in 2000 to that in 2004?
Provide a short and direct response. 0.87. What is the ratio of the % of value added in manufacturing of Brazil in 2000 to that in 2005?
Make the answer very short. 1.1. What is the ratio of the % of value added in manufacturing in Canada in 2000 to that in 2005?
Provide a succinct answer. 0.98. What is the ratio of the % of value added in manufacturing in Israel in 2000 to that in 2005?
Your answer should be very brief. 0.54. What is the ratio of the % of value added in manufacturing of Morocco in 2000 to that in 2005?
Your answer should be compact. 0.86. What is the ratio of the % of value added in manufacturing in Brazil in 2000 to that in 2006?
Make the answer very short. 1.15. What is the ratio of the % of value added in manufacturing of Canada in 2000 to that in 2006?
Give a very brief answer. 0.93. What is the ratio of the % of value added in manufacturing of Israel in 2000 to that in 2006?
Your answer should be compact. 0.51. What is the ratio of the % of value added in manufacturing of Morocco in 2000 to that in 2006?
Your answer should be compact. 0.93. What is the ratio of the % of value added in manufacturing in Brazil in 2000 to that in 2007?
Make the answer very short. 1.11. What is the ratio of the % of value added in manufacturing in Canada in 2000 to that in 2007?
Your answer should be very brief. 0.96. What is the ratio of the % of value added in manufacturing in Israel in 2000 to that in 2007?
Give a very brief answer. 0.54. What is the ratio of the % of value added in manufacturing of Morocco in 2000 to that in 2007?
Offer a very short reply. 0.74. What is the ratio of the % of value added in manufacturing of Canada in 2001 to that in 2002?
Keep it short and to the point. 0.96. What is the ratio of the % of value added in manufacturing of Israel in 2001 to that in 2002?
Give a very brief answer. 0.83. What is the ratio of the % of value added in manufacturing of Morocco in 2001 to that in 2002?
Ensure brevity in your answer.  0.97. What is the ratio of the % of value added in manufacturing of Brazil in 2001 to that in 2003?
Offer a terse response. 1. What is the ratio of the % of value added in manufacturing of Canada in 2001 to that in 2003?
Keep it short and to the point. 0.91. What is the ratio of the % of value added in manufacturing in Israel in 2001 to that in 2003?
Keep it short and to the point. 0.79. What is the ratio of the % of value added in manufacturing in Morocco in 2001 to that in 2003?
Provide a short and direct response. 0.89. What is the ratio of the % of value added in manufacturing in Canada in 2001 to that in 2004?
Offer a very short reply. 1.13. What is the ratio of the % of value added in manufacturing in Israel in 2001 to that in 2004?
Provide a short and direct response. 0.64. What is the ratio of the % of value added in manufacturing in Morocco in 2001 to that in 2004?
Make the answer very short. 0.9. What is the ratio of the % of value added in manufacturing in Brazil in 2001 to that in 2005?
Make the answer very short. 1.07. What is the ratio of the % of value added in manufacturing of Canada in 2001 to that in 2005?
Your response must be concise. 1.07. What is the ratio of the % of value added in manufacturing in Israel in 2001 to that in 2005?
Make the answer very short. 0.55. What is the ratio of the % of value added in manufacturing of Morocco in 2001 to that in 2005?
Keep it short and to the point. 0.89. What is the ratio of the % of value added in manufacturing of Brazil in 2001 to that in 2006?
Your answer should be very brief. 1.12. What is the ratio of the % of value added in manufacturing of Canada in 2001 to that in 2006?
Your answer should be compact. 1.01. What is the ratio of the % of value added in manufacturing in Israel in 2001 to that in 2006?
Make the answer very short. 0.52. What is the ratio of the % of value added in manufacturing in Morocco in 2001 to that in 2006?
Your answer should be compact. 0.96. What is the ratio of the % of value added in manufacturing in Brazil in 2001 to that in 2007?
Your answer should be very brief. 1.08. What is the ratio of the % of value added in manufacturing of Canada in 2001 to that in 2007?
Your answer should be compact. 1.05. What is the ratio of the % of value added in manufacturing in Israel in 2001 to that in 2007?
Offer a terse response. 0.55. What is the ratio of the % of value added in manufacturing in Morocco in 2001 to that in 2007?
Offer a terse response. 0.77. What is the ratio of the % of value added in manufacturing of Canada in 2002 to that in 2003?
Give a very brief answer. 0.95. What is the ratio of the % of value added in manufacturing of Israel in 2002 to that in 2003?
Offer a terse response. 0.95. What is the ratio of the % of value added in manufacturing of Morocco in 2002 to that in 2003?
Ensure brevity in your answer.  0.91. What is the ratio of the % of value added in manufacturing in Brazil in 2002 to that in 2004?
Ensure brevity in your answer.  1. What is the ratio of the % of value added in manufacturing in Canada in 2002 to that in 2004?
Keep it short and to the point. 1.18. What is the ratio of the % of value added in manufacturing in Israel in 2002 to that in 2004?
Provide a short and direct response. 0.77. What is the ratio of the % of value added in manufacturing in Morocco in 2002 to that in 2004?
Keep it short and to the point. 0.93. What is the ratio of the % of value added in manufacturing in Brazil in 2002 to that in 2005?
Your response must be concise. 1.06. What is the ratio of the % of value added in manufacturing of Canada in 2002 to that in 2005?
Your answer should be compact. 1.12. What is the ratio of the % of value added in manufacturing of Israel in 2002 to that in 2005?
Provide a succinct answer. 0.66. What is the ratio of the % of value added in manufacturing in Brazil in 2002 to that in 2006?
Keep it short and to the point. 1.12. What is the ratio of the % of value added in manufacturing of Canada in 2002 to that in 2006?
Your answer should be very brief. 1.05. What is the ratio of the % of value added in manufacturing in Israel in 2002 to that in 2006?
Keep it short and to the point. 0.62. What is the ratio of the % of value added in manufacturing of Morocco in 2002 to that in 2006?
Give a very brief answer. 0.98. What is the ratio of the % of value added in manufacturing in Brazil in 2002 to that in 2007?
Give a very brief answer. 1.07. What is the ratio of the % of value added in manufacturing of Canada in 2002 to that in 2007?
Your answer should be compact. 1.09. What is the ratio of the % of value added in manufacturing of Israel in 2002 to that in 2007?
Your answer should be compact. 0.66. What is the ratio of the % of value added in manufacturing of Morocco in 2002 to that in 2007?
Your answer should be compact. 0.79. What is the ratio of the % of value added in manufacturing in Canada in 2003 to that in 2004?
Make the answer very short. 1.24. What is the ratio of the % of value added in manufacturing in Israel in 2003 to that in 2004?
Your response must be concise. 0.81. What is the ratio of the % of value added in manufacturing in Morocco in 2003 to that in 2004?
Offer a very short reply. 1.01. What is the ratio of the % of value added in manufacturing in Brazil in 2003 to that in 2005?
Make the answer very short. 1.07. What is the ratio of the % of value added in manufacturing in Canada in 2003 to that in 2005?
Your response must be concise. 1.17. What is the ratio of the % of value added in manufacturing of Israel in 2003 to that in 2005?
Offer a terse response. 0.7. What is the ratio of the % of value added in manufacturing in Brazil in 2003 to that in 2006?
Offer a very short reply. 1.12. What is the ratio of the % of value added in manufacturing of Canada in 2003 to that in 2006?
Make the answer very short. 1.1. What is the ratio of the % of value added in manufacturing in Israel in 2003 to that in 2006?
Give a very brief answer. 0.66. What is the ratio of the % of value added in manufacturing in Morocco in 2003 to that in 2006?
Offer a terse response. 1.08. What is the ratio of the % of value added in manufacturing in Brazil in 2003 to that in 2007?
Ensure brevity in your answer.  1.08. What is the ratio of the % of value added in manufacturing in Canada in 2003 to that in 2007?
Give a very brief answer. 1.15. What is the ratio of the % of value added in manufacturing of Israel in 2003 to that in 2007?
Offer a very short reply. 0.7. What is the ratio of the % of value added in manufacturing in Morocco in 2003 to that in 2007?
Offer a terse response. 0.86. What is the ratio of the % of value added in manufacturing in Brazil in 2004 to that in 2005?
Provide a succinct answer. 1.07. What is the ratio of the % of value added in manufacturing of Canada in 2004 to that in 2005?
Provide a succinct answer. 0.95. What is the ratio of the % of value added in manufacturing in Israel in 2004 to that in 2005?
Give a very brief answer. 0.86. What is the ratio of the % of value added in manufacturing in Morocco in 2004 to that in 2005?
Provide a succinct answer. 0.99. What is the ratio of the % of value added in manufacturing in Brazil in 2004 to that in 2006?
Your response must be concise. 1.12. What is the ratio of the % of value added in manufacturing in Canada in 2004 to that in 2006?
Ensure brevity in your answer.  0.89. What is the ratio of the % of value added in manufacturing in Israel in 2004 to that in 2006?
Your response must be concise. 0.81. What is the ratio of the % of value added in manufacturing in Morocco in 2004 to that in 2006?
Your answer should be very brief. 1.06. What is the ratio of the % of value added in manufacturing in Brazil in 2004 to that in 2007?
Offer a terse response. 1.08. What is the ratio of the % of value added in manufacturing in Canada in 2004 to that in 2007?
Your answer should be very brief. 0.93. What is the ratio of the % of value added in manufacturing of Israel in 2004 to that in 2007?
Provide a succinct answer. 0.86. What is the ratio of the % of value added in manufacturing in Morocco in 2004 to that in 2007?
Your response must be concise. 0.85. What is the ratio of the % of value added in manufacturing of Brazil in 2005 to that in 2006?
Ensure brevity in your answer.  1.05. What is the ratio of the % of value added in manufacturing of Canada in 2005 to that in 2006?
Your answer should be very brief. 0.94. What is the ratio of the % of value added in manufacturing of Israel in 2005 to that in 2006?
Your answer should be compact. 0.94. What is the ratio of the % of value added in manufacturing in Morocco in 2005 to that in 2006?
Offer a terse response. 1.08. What is the ratio of the % of value added in manufacturing of Canada in 2005 to that in 2007?
Keep it short and to the point. 0.98. What is the ratio of the % of value added in manufacturing in Israel in 2005 to that in 2007?
Your response must be concise. 0.99. What is the ratio of the % of value added in manufacturing in Morocco in 2005 to that in 2007?
Your answer should be very brief. 0.86. What is the ratio of the % of value added in manufacturing of Canada in 2006 to that in 2007?
Provide a succinct answer. 1.04. What is the ratio of the % of value added in manufacturing of Israel in 2006 to that in 2007?
Keep it short and to the point. 1.06. What is the ratio of the % of value added in manufacturing in Morocco in 2006 to that in 2007?
Ensure brevity in your answer.  0.8. What is the difference between the highest and the second highest % of value added in manufacturing in Brazil?
Your answer should be very brief. 0.32. What is the difference between the highest and the second highest % of value added in manufacturing in Canada?
Keep it short and to the point. 0.41. What is the difference between the highest and the second highest % of value added in manufacturing of Israel?
Give a very brief answer. 1.18. What is the difference between the highest and the second highest % of value added in manufacturing of Morocco?
Your answer should be very brief. 2.25. What is the difference between the highest and the lowest % of value added in manufacturing in Brazil?
Offer a terse response. 1.63. What is the difference between the highest and the lowest % of value added in manufacturing in Canada?
Your response must be concise. 1.71. What is the difference between the highest and the lowest % of value added in manufacturing in Israel?
Provide a short and direct response. 10.05. What is the difference between the highest and the lowest % of value added in manufacturing of Morocco?
Make the answer very short. 4.23. 